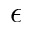<formula> <loc_0><loc_0><loc_500><loc_500>\epsilon</formula> 